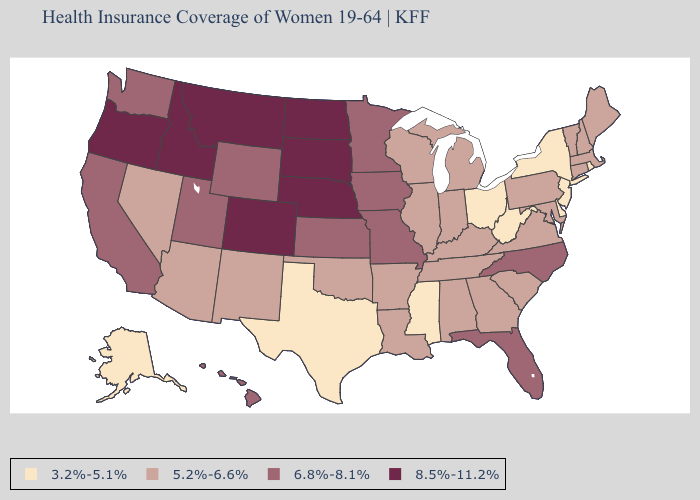Is the legend a continuous bar?
Give a very brief answer. No. What is the lowest value in states that border Iowa?
Be succinct. 5.2%-6.6%. What is the lowest value in states that border Rhode Island?
Be succinct. 5.2%-6.6%. What is the value of Kentucky?
Quick response, please. 5.2%-6.6%. Does Maine have a higher value than California?
Give a very brief answer. No. Does Washington have a higher value than Nebraska?
Short answer required. No. What is the lowest value in states that border Kentucky?
Keep it brief. 3.2%-5.1%. What is the value of Kansas?
Answer briefly. 6.8%-8.1%. What is the value of Utah?
Be succinct. 6.8%-8.1%. Name the states that have a value in the range 6.8%-8.1%?
Concise answer only. California, Florida, Hawaii, Iowa, Kansas, Minnesota, Missouri, North Carolina, Utah, Washington, Wyoming. What is the value of Kansas?
Concise answer only. 6.8%-8.1%. Does the map have missing data?
Keep it brief. No. Which states hav the highest value in the Northeast?
Answer briefly. Connecticut, Maine, Massachusetts, New Hampshire, Pennsylvania, Vermont. 